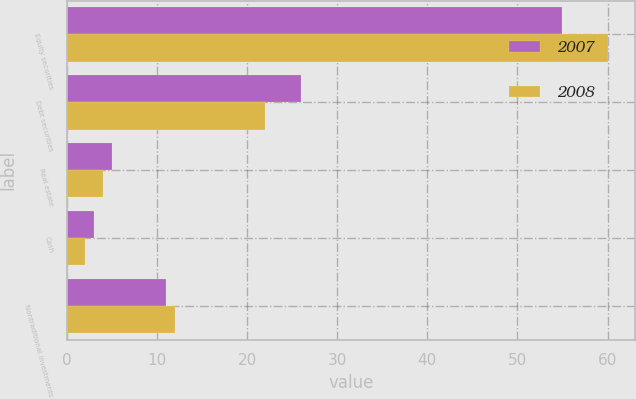Convert chart. <chart><loc_0><loc_0><loc_500><loc_500><stacked_bar_chart><ecel><fcel>Equity securities<fcel>Debt securities<fcel>Real estate<fcel>Cash<fcel>Nontraditional investments<nl><fcel>2007<fcel>55<fcel>26<fcel>5<fcel>3<fcel>11<nl><fcel>2008<fcel>60<fcel>22<fcel>4<fcel>2<fcel>12<nl></chart> 